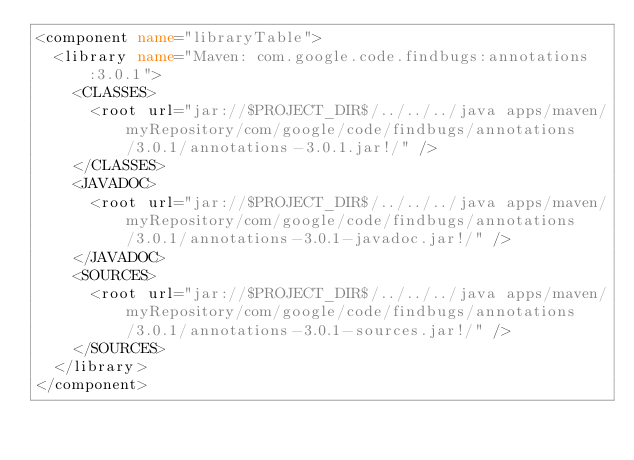<code> <loc_0><loc_0><loc_500><loc_500><_XML_><component name="libraryTable">
  <library name="Maven: com.google.code.findbugs:annotations:3.0.1">
    <CLASSES>
      <root url="jar://$PROJECT_DIR$/../../../java apps/maven/myRepository/com/google/code/findbugs/annotations/3.0.1/annotations-3.0.1.jar!/" />
    </CLASSES>
    <JAVADOC>
      <root url="jar://$PROJECT_DIR$/../../../java apps/maven/myRepository/com/google/code/findbugs/annotations/3.0.1/annotations-3.0.1-javadoc.jar!/" />
    </JAVADOC>
    <SOURCES>
      <root url="jar://$PROJECT_DIR$/../../../java apps/maven/myRepository/com/google/code/findbugs/annotations/3.0.1/annotations-3.0.1-sources.jar!/" />
    </SOURCES>
  </library>
</component></code> 